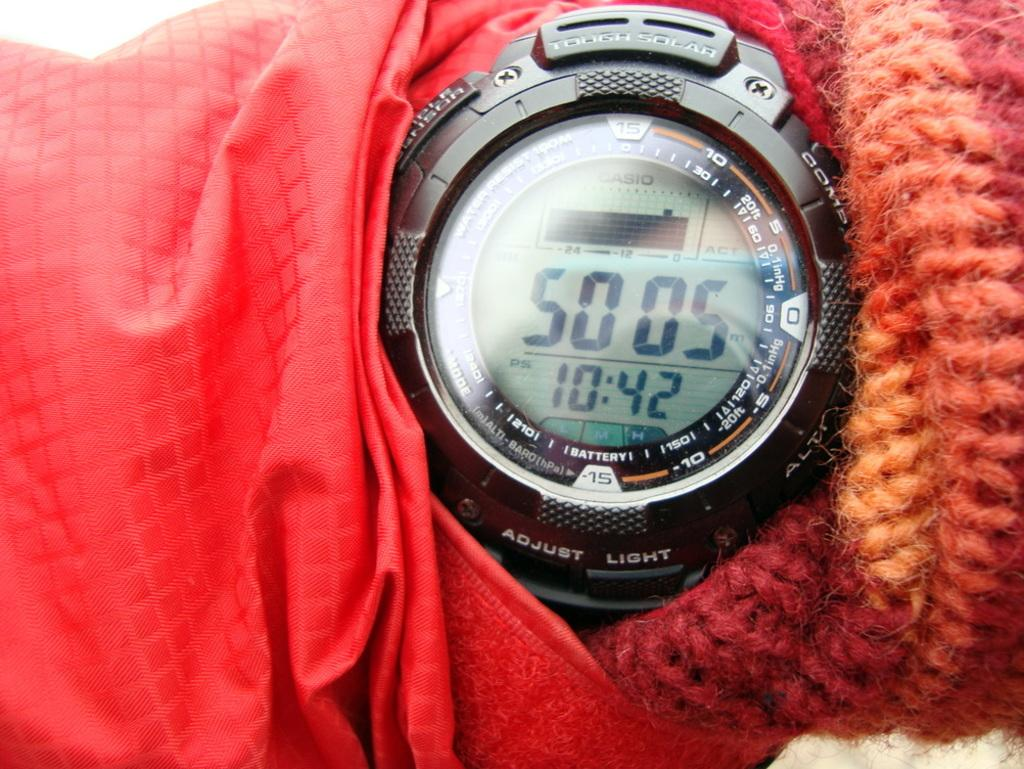<image>
Present a compact description of the photo's key features. the persons black watch says 50 05 and 10:42 